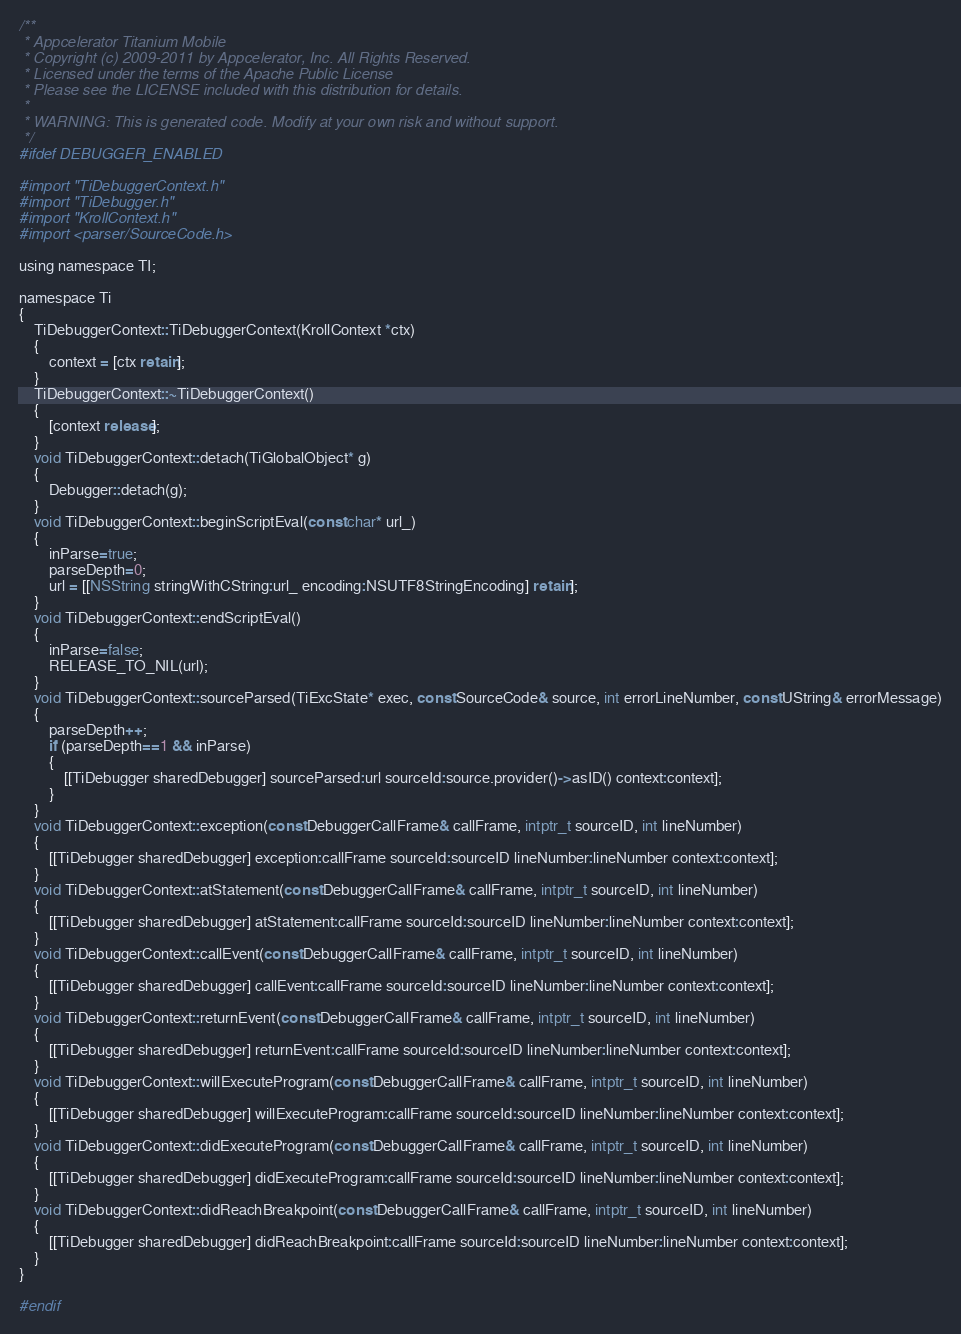Convert code to text. <code><loc_0><loc_0><loc_500><loc_500><_ObjectiveC_>/**
 * Appcelerator Titanium Mobile
 * Copyright (c) 2009-2011 by Appcelerator, Inc. All Rights Reserved.
 * Licensed under the terms of the Apache Public License
 * Please see the LICENSE included with this distribution for details.
 * 
 * WARNING: This is generated code. Modify at your own risk and without support.
 */
#ifdef DEBUGGER_ENABLED

#import "TiDebuggerContext.h"
#import "TiDebugger.h"
#import "KrollContext.h"
#import <parser/SourceCode.h>

using namespace TI;

namespace Ti
{
	TiDebuggerContext::TiDebuggerContext(KrollContext *ctx)
	{
		context = [ctx retain];
	}
	TiDebuggerContext::~TiDebuggerContext()
	{
		[context release];
	}
	void TiDebuggerContext::detach(TiGlobalObject* g)
	{
		Debugger::detach(g);
	}
	void TiDebuggerContext::beginScriptEval(const char* url_)
	{
		inParse=true;
		parseDepth=0;
		url = [[NSString stringWithCString:url_ encoding:NSUTF8StringEncoding] retain];
	}
	void TiDebuggerContext::endScriptEval()
	{
		inParse=false;
		RELEASE_TO_NIL(url);
	}
	void TiDebuggerContext::sourceParsed(TiExcState* exec, const SourceCode& source, int errorLineNumber, const UString& errorMessage)
	{
		parseDepth++;
		if (parseDepth==1 && inParse)
		{
			[[TiDebugger sharedDebugger] sourceParsed:url sourceId:source.provider()->asID() context:context];
		}
	}
	void TiDebuggerContext::exception(const DebuggerCallFrame& callFrame, intptr_t sourceID, int lineNumber)
	{
		[[TiDebugger sharedDebugger] exception:callFrame sourceId:sourceID lineNumber:lineNumber context:context];
	}
	void TiDebuggerContext::atStatement(const DebuggerCallFrame& callFrame, intptr_t sourceID, int lineNumber)
	{
		[[TiDebugger sharedDebugger] atStatement:callFrame sourceId:sourceID lineNumber:lineNumber context:context];
	}
	void TiDebuggerContext::callEvent(const DebuggerCallFrame& callFrame, intptr_t sourceID, int lineNumber)
	{
		[[TiDebugger sharedDebugger] callEvent:callFrame sourceId:sourceID lineNumber:lineNumber context:context];
	}
	void TiDebuggerContext::returnEvent(const DebuggerCallFrame& callFrame, intptr_t sourceID, int lineNumber)
	{
		[[TiDebugger sharedDebugger] returnEvent:callFrame sourceId:sourceID lineNumber:lineNumber context:context];
	}
	void TiDebuggerContext::willExecuteProgram(const DebuggerCallFrame& callFrame, intptr_t sourceID, int lineNumber)
	{
		[[TiDebugger sharedDebugger] willExecuteProgram:callFrame sourceId:sourceID lineNumber:lineNumber context:context];
	}
	void TiDebuggerContext::didExecuteProgram(const DebuggerCallFrame& callFrame, intptr_t sourceID, int lineNumber)
	{
		[[TiDebugger sharedDebugger] didExecuteProgram:callFrame sourceId:sourceID lineNumber:lineNumber context:context];
	}
	void TiDebuggerContext::didReachBreakpoint(const DebuggerCallFrame& callFrame, intptr_t sourceID, int lineNumber)
	{
		[[TiDebugger sharedDebugger] didReachBreakpoint:callFrame sourceId:sourceID lineNumber:lineNumber context:context];
	}
}

#endif
</code> 